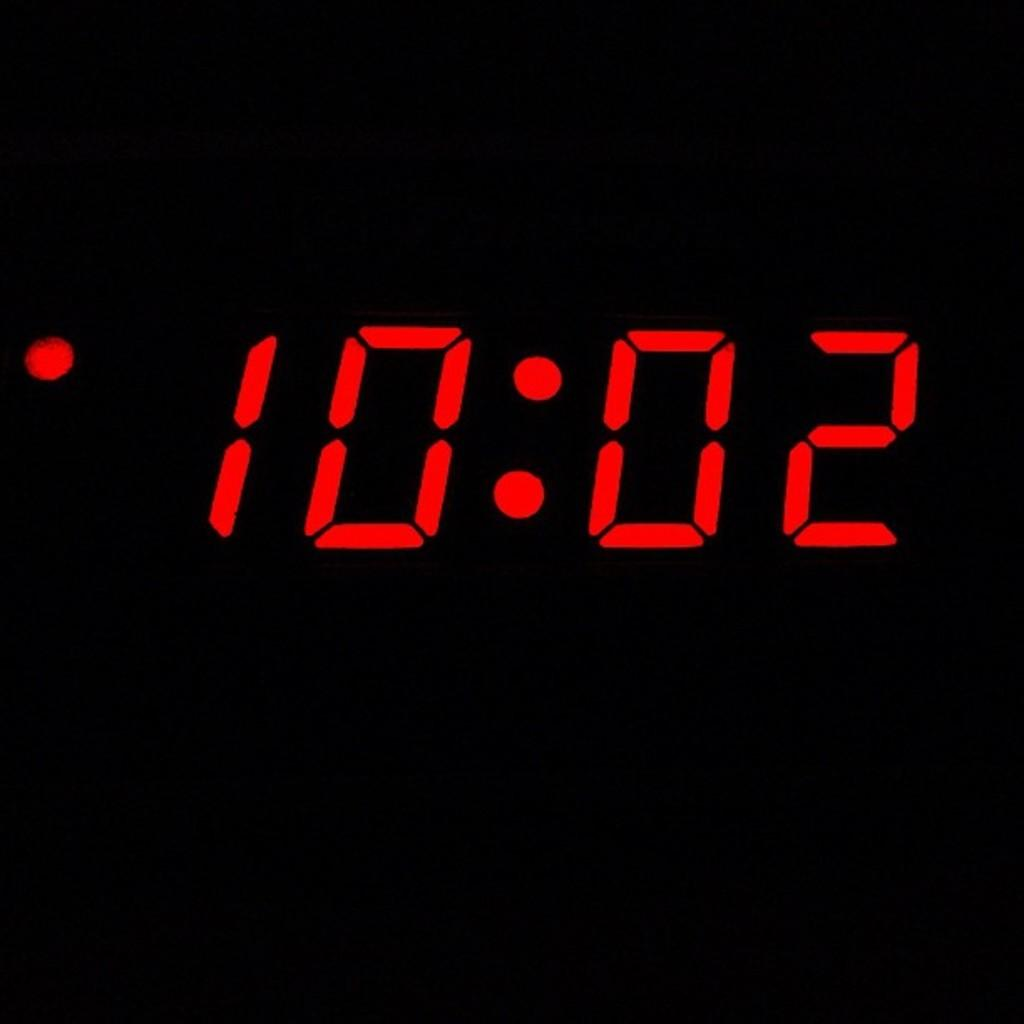<image>
Describe the image concisely. Screen of a digital clock that shows the time at 10:02. 